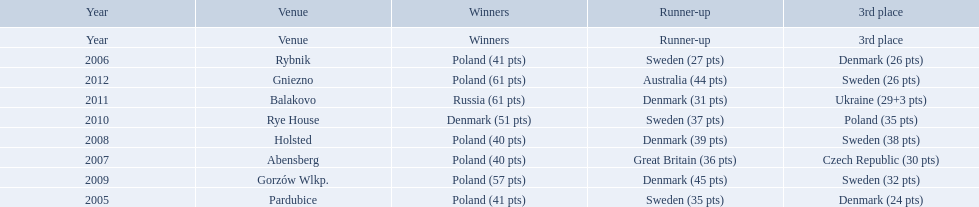After enjoying five consecutive victories at the team speedway junior world championship poland was finally unseated in what year? 2010. In that year, what teams placed first through third? Denmark (51 pts), Sweden (37 pts), Poland (35 pts). Which of those positions did poland specifically place in? 3rd place. 